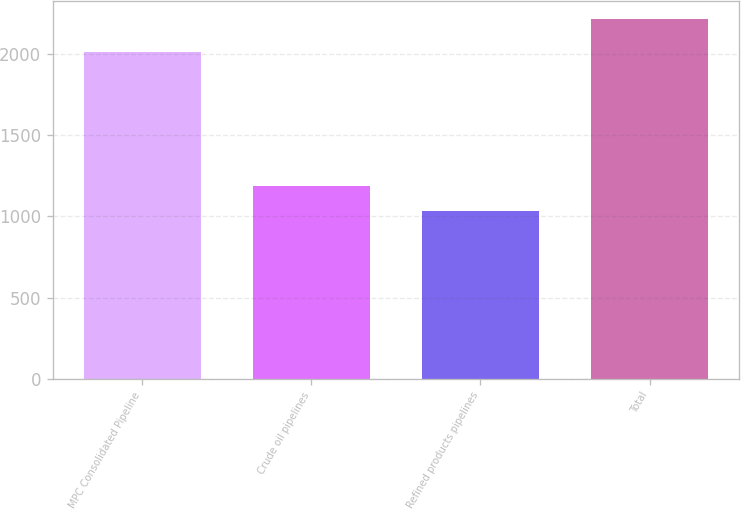Convert chart to OTSL. <chart><loc_0><loc_0><loc_500><loc_500><bar_chart><fcel>MPC Consolidated Pipeline<fcel>Crude oil pipelines<fcel>Refined products pipelines<fcel>Total<nl><fcel>2011<fcel>1184<fcel>1031<fcel>2215<nl></chart> 